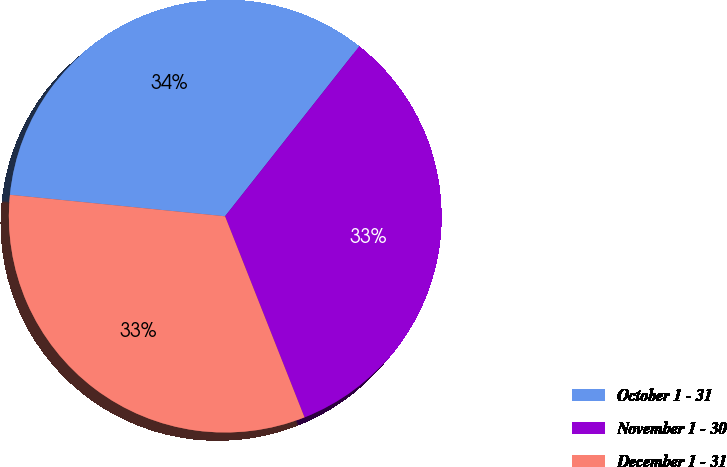Convert chart. <chart><loc_0><loc_0><loc_500><loc_500><pie_chart><fcel>October 1 - 31<fcel>November 1 - 30<fcel>December 1 - 31<nl><fcel>34.05%<fcel>33.37%<fcel>32.57%<nl></chart> 